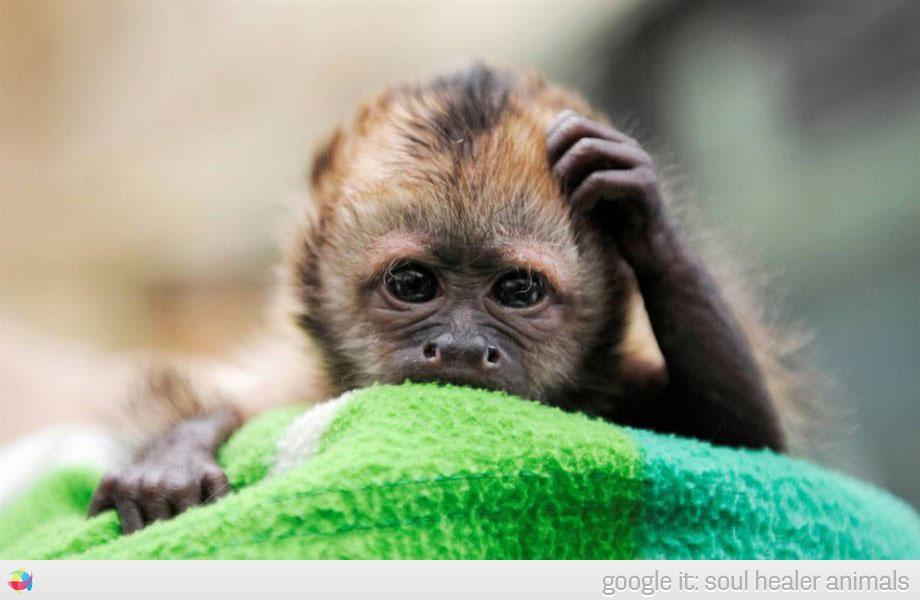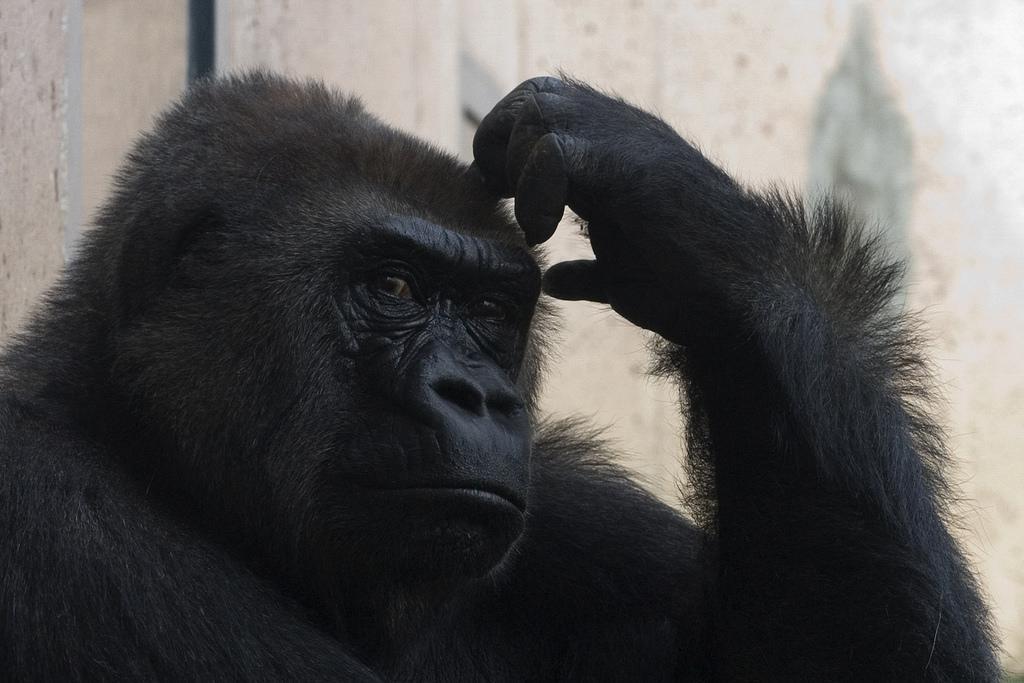The first image is the image on the left, the second image is the image on the right. Given the left and right images, does the statement "A small monkey with non-black fur scratches its head, in one image." hold true? Answer yes or no. Yes. The first image is the image on the left, the second image is the image on the right. Analyze the images presented: Is the assertion "At least one primate is sticking their tongue out." valid? Answer yes or no. No. 